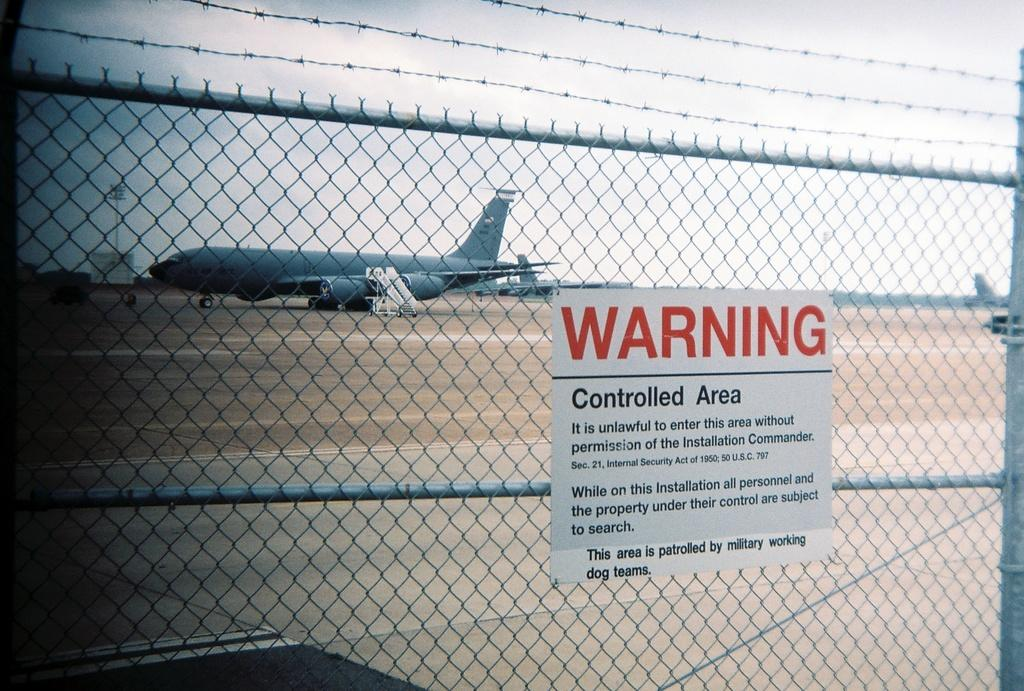<image>
Summarize the visual content of the image. Fence that have a warning controlled area sign on it 